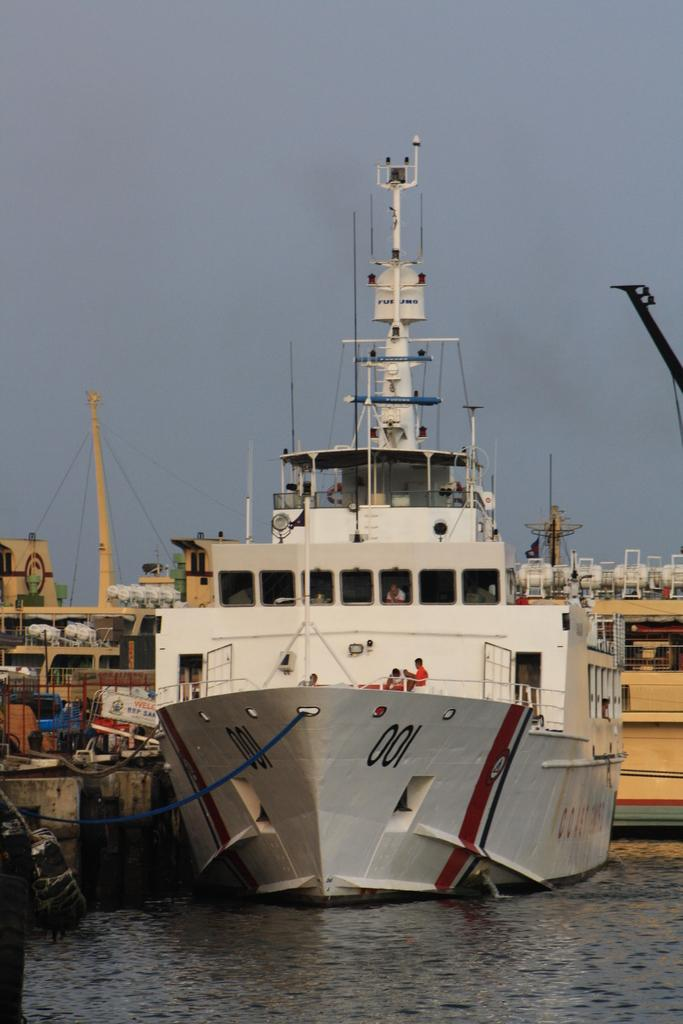What is the main subject of the image? The main subject of the image is ships on the water. Can you describe the people visible in the image? There are people visible in the image, but their specific actions or characteristics are not mentioned in the provided facts. What else can be seen in the image besides the ships and people? There are objects present in the image, but their specific nature is not mentioned in the provided facts. What is visible in the background of the image? The sky is visible in the background of the image. How does the wish affect the edge of the water in the image? There is no mention of a wish or an edge in the provided facts, so it is not possible to answer this question based on the image. 